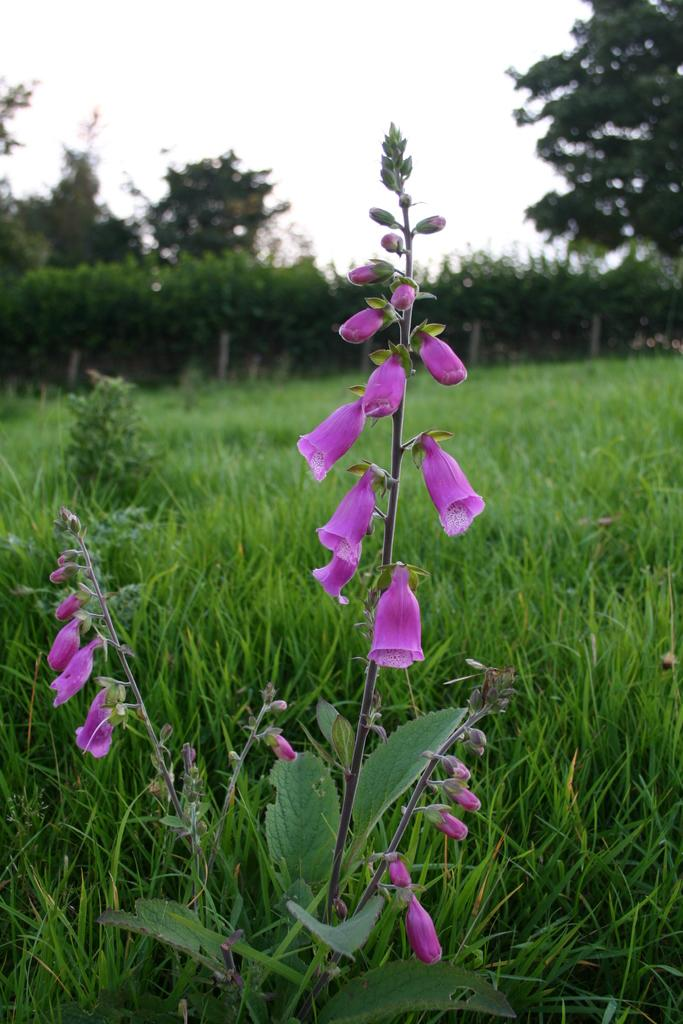What type of vegetation can be seen in the image? There are trees and a plant with flowers in the image. What is covering the ground in the image? There is grass on the ground in the image. How would you describe the sky in the image? The sky is cloudy in the image. What type of trade is being conducted in the image? There is no trade being conducted in the image; it features natural elements such as trees, flowers, grass, and the sky. Can you see a notebook in the image? There is no notebook present in the image. 